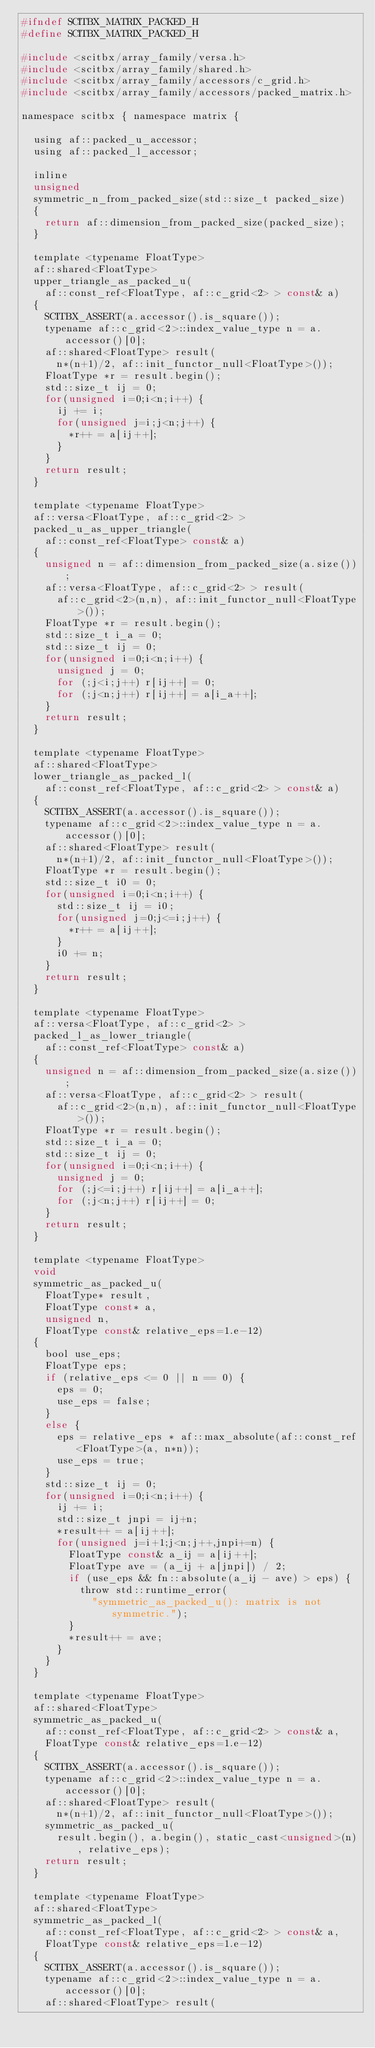Convert code to text. <code><loc_0><loc_0><loc_500><loc_500><_C_>#ifndef SCITBX_MATRIX_PACKED_H
#define SCITBX_MATRIX_PACKED_H

#include <scitbx/array_family/versa.h>
#include <scitbx/array_family/shared.h>
#include <scitbx/array_family/accessors/c_grid.h>
#include <scitbx/array_family/accessors/packed_matrix.h>

namespace scitbx { namespace matrix {

  using af::packed_u_accessor;
  using af::packed_l_accessor;

  inline
  unsigned
  symmetric_n_from_packed_size(std::size_t packed_size)
  {
    return af::dimension_from_packed_size(packed_size);
  }

  template <typename FloatType>
  af::shared<FloatType>
  upper_triangle_as_packed_u(
    af::const_ref<FloatType, af::c_grid<2> > const& a)
  {
    SCITBX_ASSERT(a.accessor().is_square());
    typename af::c_grid<2>::index_value_type n = a.accessor()[0];
    af::shared<FloatType> result(
      n*(n+1)/2, af::init_functor_null<FloatType>());
    FloatType *r = result.begin();
    std::size_t ij = 0;
    for(unsigned i=0;i<n;i++) {
      ij += i;
      for(unsigned j=i;j<n;j++) {
        *r++ = a[ij++];
      }
    }
    return result;
  }

  template <typename FloatType>
  af::versa<FloatType, af::c_grid<2> >
  packed_u_as_upper_triangle(
    af::const_ref<FloatType> const& a)
  {
    unsigned n = af::dimension_from_packed_size(a.size());
    af::versa<FloatType, af::c_grid<2> > result(
      af::c_grid<2>(n,n), af::init_functor_null<FloatType>());
    FloatType *r = result.begin();
    std::size_t i_a = 0;
    std::size_t ij = 0;
    for(unsigned i=0;i<n;i++) {
      unsigned j = 0;
      for (;j<i;j++) r[ij++] = 0;
      for (;j<n;j++) r[ij++] = a[i_a++];
    }
    return result;
  }

  template <typename FloatType>
  af::shared<FloatType>
  lower_triangle_as_packed_l(
    af::const_ref<FloatType, af::c_grid<2> > const& a)
  {
    SCITBX_ASSERT(a.accessor().is_square());
    typename af::c_grid<2>::index_value_type n = a.accessor()[0];
    af::shared<FloatType> result(
      n*(n+1)/2, af::init_functor_null<FloatType>());
    FloatType *r = result.begin();
    std::size_t i0 = 0;
    for(unsigned i=0;i<n;i++) {
      std::size_t ij = i0;
      for(unsigned j=0;j<=i;j++) {
        *r++ = a[ij++];
      }
      i0 += n;
    }
    return result;
  }

  template <typename FloatType>
  af::versa<FloatType, af::c_grid<2> >
  packed_l_as_lower_triangle(
    af::const_ref<FloatType> const& a)
  {
    unsigned n = af::dimension_from_packed_size(a.size());
    af::versa<FloatType, af::c_grid<2> > result(
      af::c_grid<2>(n,n), af::init_functor_null<FloatType>());
    FloatType *r = result.begin();
    std::size_t i_a = 0;
    std::size_t ij = 0;
    for(unsigned i=0;i<n;i++) {
      unsigned j = 0;
      for (;j<=i;j++) r[ij++] = a[i_a++];
      for (;j<n;j++) r[ij++] = 0;
    }
    return result;
  }

  template <typename FloatType>
  void
  symmetric_as_packed_u(
    FloatType* result,
    FloatType const* a,
    unsigned n,
    FloatType const& relative_eps=1.e-12)
  {
    bool use_eps;
    FloatType eps;
    if (relative_eps <= 0 || n == 0) {
      eps = 0;
      use_eps = false;
    }
    else {
      eps = relative_eps * af::max_absolute(af::const_ref<FloatType>(a, n*n));
      use_eps = true;
    }
    std::size_t ij = 0;
    for(unsigned i=0;i<n;i++) {
      ij += i;
      std::size_t jnpi = ij+n;
      *result++ = a[ij++];
      for(unsigned j=i+1;j<n;j++,jnpi+=n) {
        FloatType const& a_ij = a[ij++];
        FloatType ave = (a_ij + a[jnpi]) / 2;
        if (use_eps && fn::absolute(a_ij - ave) > eps) {
          throw std::runtime_error(
            "symmetric_as_packed_u(): matrix is not symmetric.");
        }
        *result++ = ave;
      }
    }
  }

  template <typename FloatType>
  af::shared<FloatType>
  symmetric_as_packed_u(
    af::const_ref<FloatType, af::c_grid<2> > const& a,
    FloatType const& relative_eps=1.e-12)
  {
    SCITBX_ASSERT(a.accessor().is_square());
    typename af::c_grid<2>::index_value_type n = a.accessor()[0];
    af::shared<FloatType> result(
      n*(n+1)/2, af::init_functor_null<FloatType>());
    symmetric_as_packed_u(
      result.begin(), a.begin(), static_cast<unsigned>(n), relative_eps);
    return result;
  }

  template <typename FloatType>
  af::shared<FloatType>
  symmetric_as_packed_l(
    af::const_ref<FloatType, af::c_grid<2> > const& a,
    FloatType const& relative_eps=1.e-12)
  {
    SCITBX_ASSERT(a.accessor().is_square());
    typename af::c_grid<2>::index_value_type n = a.accessor()[0];
    af::shared<FloatType> result(</code> 